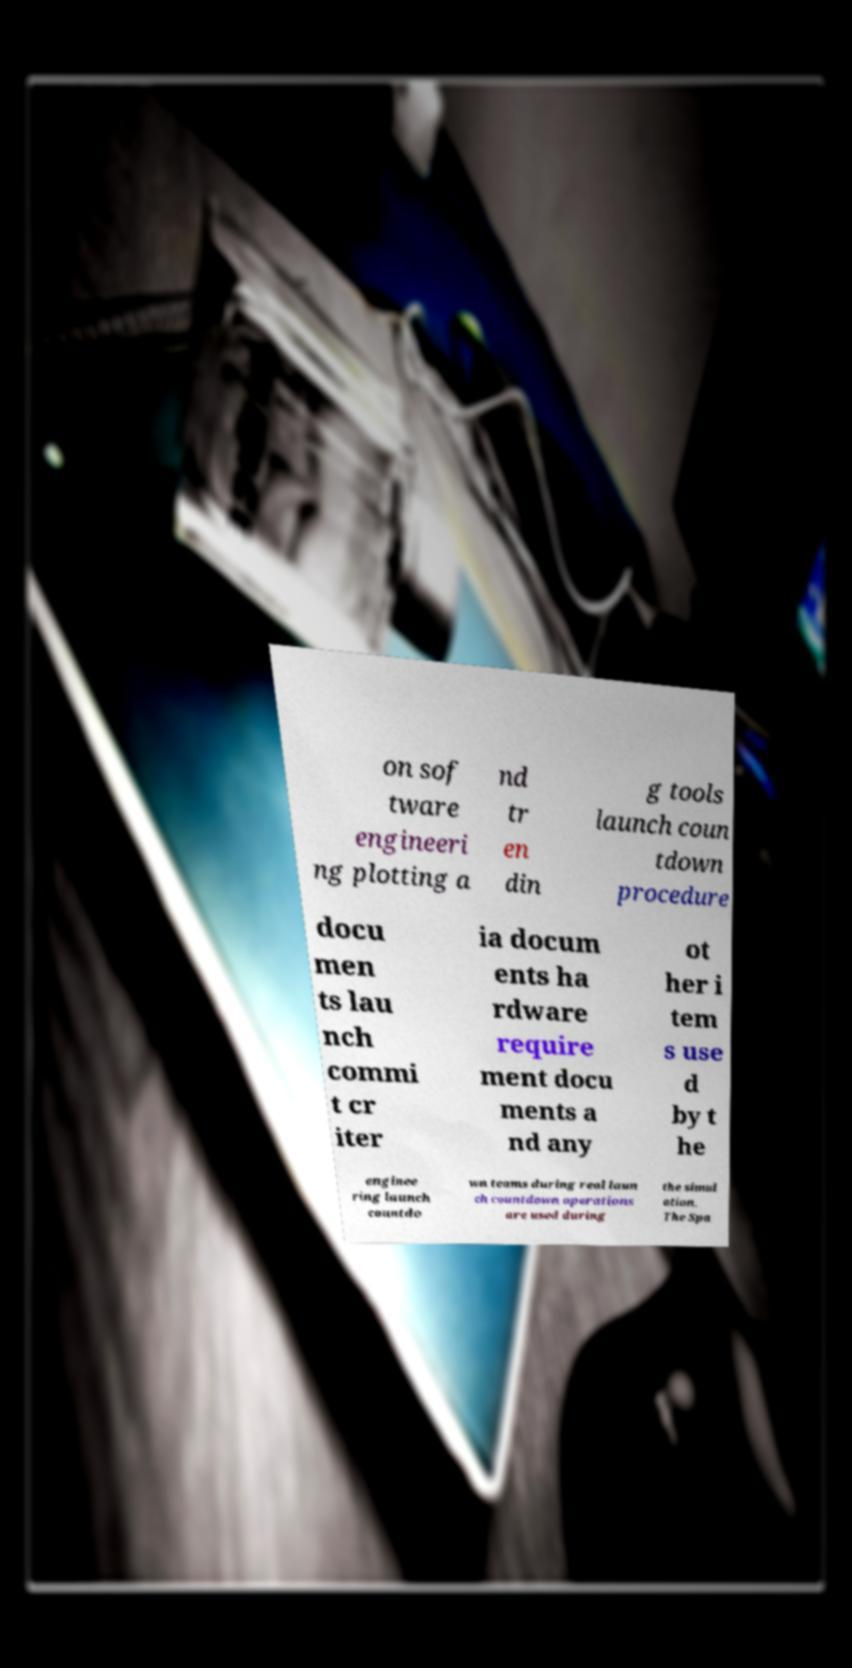Could you assist in decoding the text presented in this image and type it out clearly? on sof tware engineeri ng plotting a nd tr en din g tools launch coun tdown procedure docu men ts lau nch commi t cr iter ia docum ents ha rdware require ment docu ments a nd any ot her i tem s use d by t he enginee ring launch countdo wn teams during real laun ch countdown operations are used during the simul ation. The Spa 